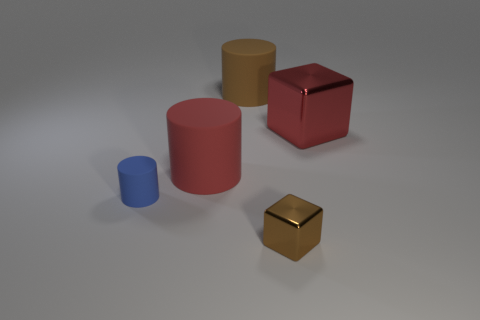Are there any patterns on the surface where the objects are placed? No discernable patterns are visible on the surface. It appears to be a uniform, solid color that provides a neutral background for the objects. 